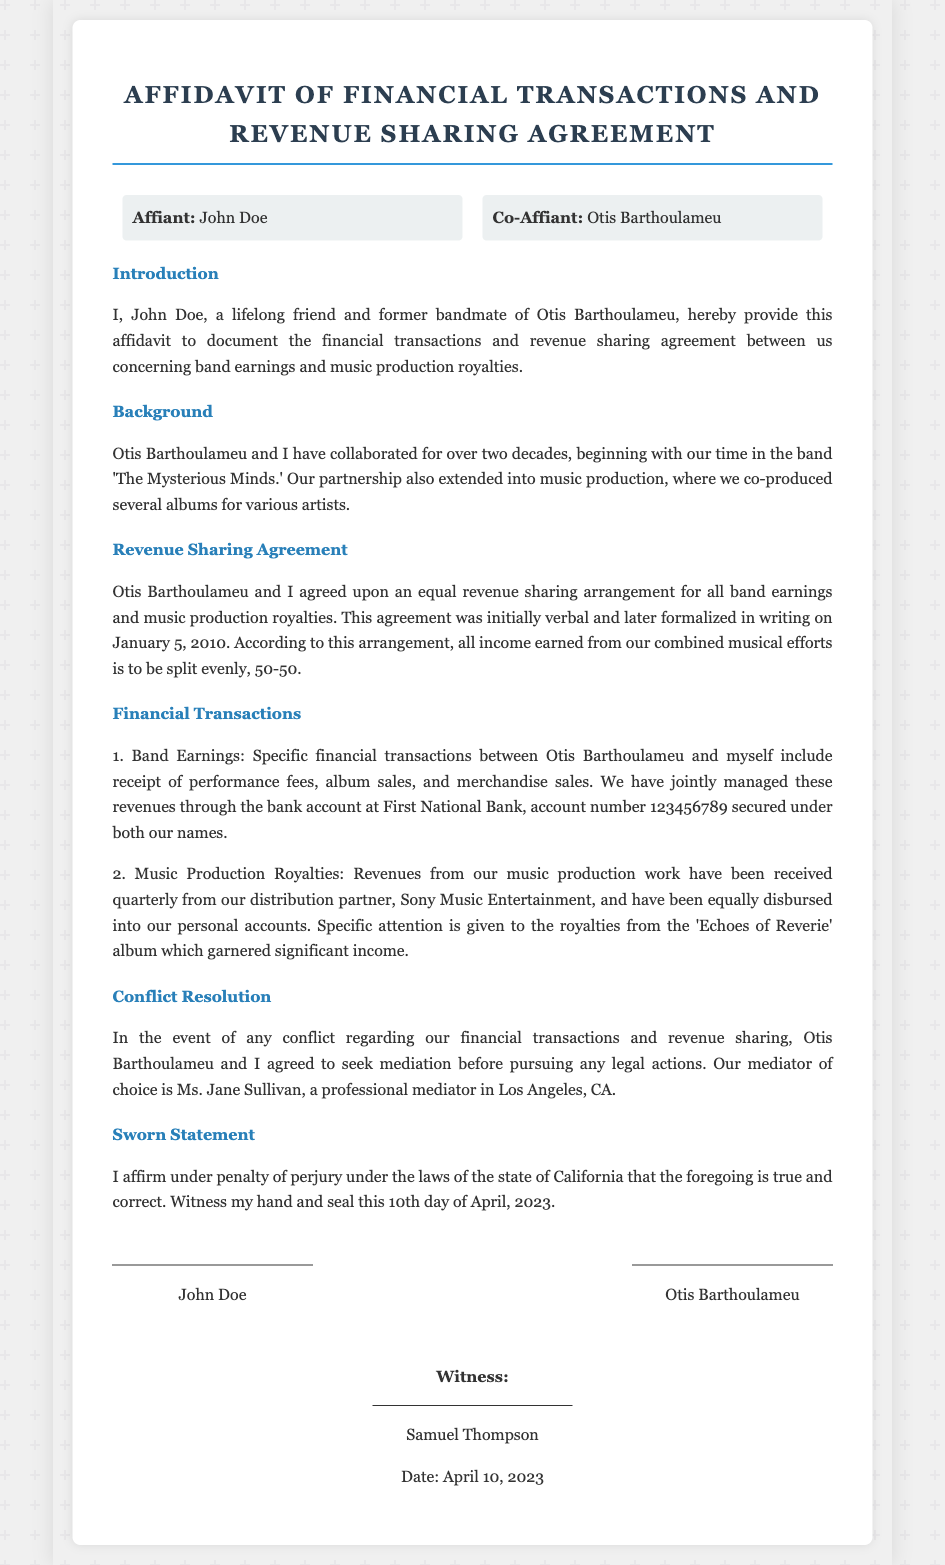What is the name of the affiant? The affiant is the individual declaring the affidavit, which is stated as John Doe.
Answer: John Doe Who is the co-affiant? The co-affiant is the individual who is also part of this affidavit, noted as Otis Barthoulameu.
Answer: Otis Barthoulameu What is the name of the bank mentioned? The bank where the joint financial transactions are managed is specifically mentioned in the affidavit.
Answer: First National Bank What date was the revenue sharing agreement formalized? The document mentions the specific date when the revenue-sharing agreement was formalized in writing.
Answer: January 5, 2010 What is the agreed revenue split ratio? The document specifies the terms of the revenue-sharing agreement, particularly the split ratio for earnings.
Answer: 50-50 What is the name of the mediator? In case of any conflicts, the document states the name of the mediator chosen by both parties.
Answer: Ms. Jane Sullivan What album is highlighted for significant music production royalties? The affidavit refers to a specific album that generated considerable income from royalties.
Answer: Echoes of Reverie When was the affidavit signed? The document includes a sworn statement with the date it was officially signed by the affiant and co-affiant.
Answer: April 10, 2023 What is the purpose of this affidavit? The introductory section of the document outlines the main reason for creating this affidavit.
Answer: To document financial transactions and revenue sharing agreement 